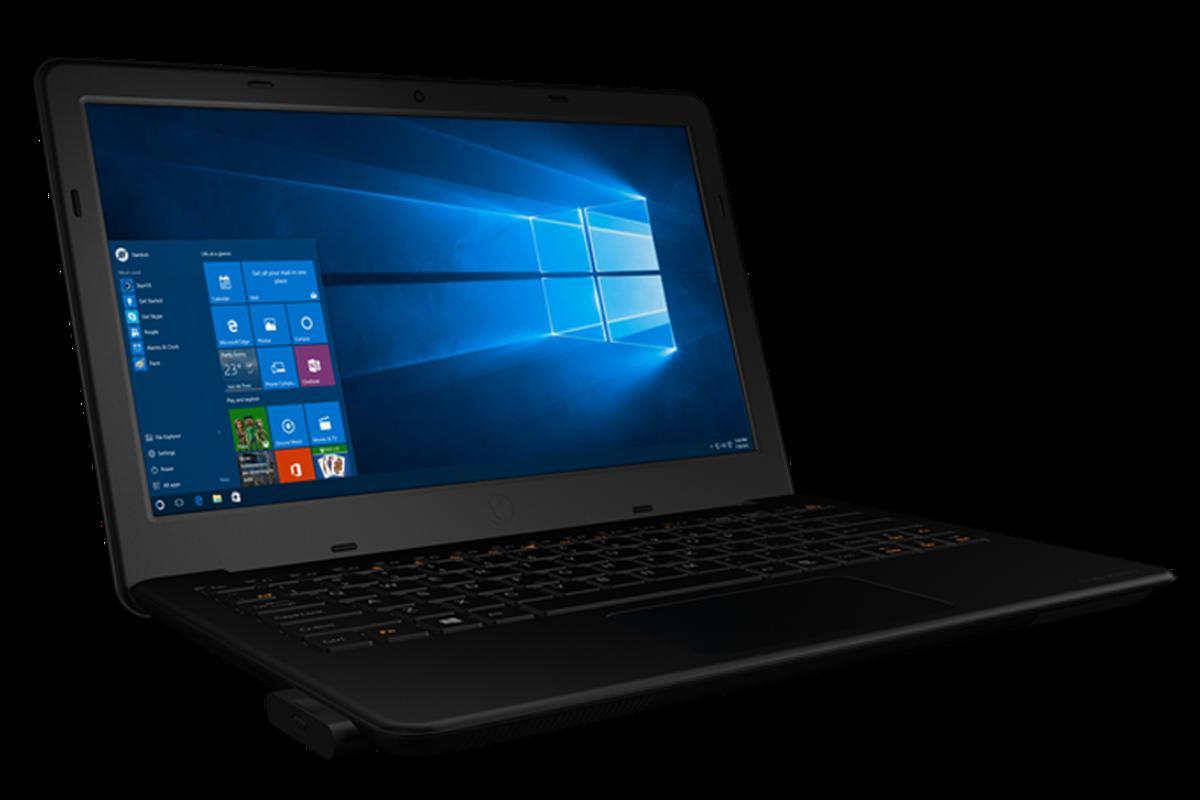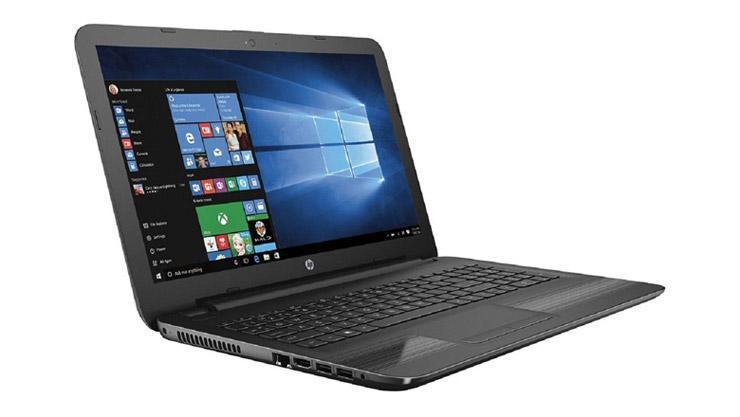The first image is the image on the left, the second image is the image on the right. For the images displayed, is the sentence "The laptops are facing towards the left side of the image." factually correct? Answer yes or no. No. 